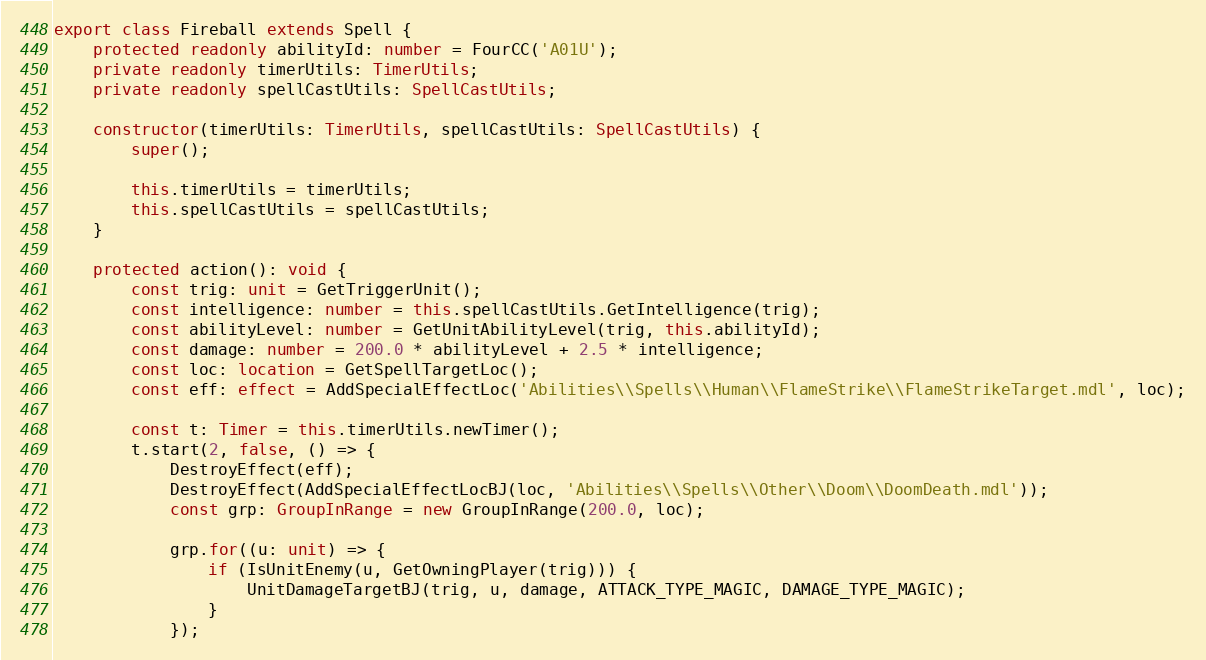<code> <loc_0><loc_0><loc_500><loc_500><_TypeScript_>export class Fireball extends Spell {
    protected readonly abilityId: number = FourCC('A01U');
    private readonly timerUtils: TimerUtils;
    private readonly spellCastUtils: SpellCastUtils;

    constructor(timerUtils: TimerUtils, spellCastUtils: SpellCastUtils) {
        super();

        this.timerUtils = timerUtils;
        this.spellCastUtils = spellCastUtils;
    }

    protected action(): void {
        const trig: unit = GetTriggerUnit();
        const intelligence: number = this.spellCastUtils.GetIntelligence(trig);
        const abilityLevel: number = GetUnitAbilityLevel(trig, this.abilityId);
        const damage: number = 200.0 * abilityLevel + 2.5 * intelligence;
        const loc: location = GetSpellTargetLoc();
        const eff: effect = AddSpecialEffectLoc('Abilities\\Spells\\Human\\FlameStrike\\FlameStrikeTarget.mdl', loc);

        const t: Timer = this.timerUtils.newTimer();
        t.start(2, false, () => {
            DestroyEffect(eff);
            DestroyEffect(AddSpecialEffectLocBJ(loc, 'Abilities\\Spells\\Other\\Doom\\DoomDeath.mdl'));
            const grp: GroupInRange = new GroupInRange(200.0, loc);

            grp.for((u: unit) => {
                if (IsUnitEnemy(u, GetOwningPlayer(trig))) {
                    UnitDamageTargetBJ(trig, u, damage, ATTACK_TYPE_MAGIC, DAMAGE_TYPE_MAGIC);
                }
            });
</code> 